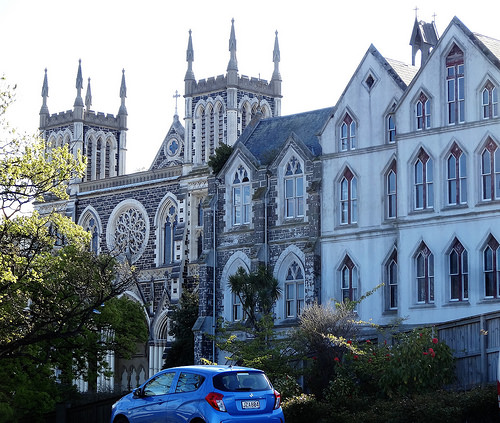<image>
Is there a car in front of the tree? Yes. The car is positioned in front of the tree, appearing closer to the camera viewpoint. 